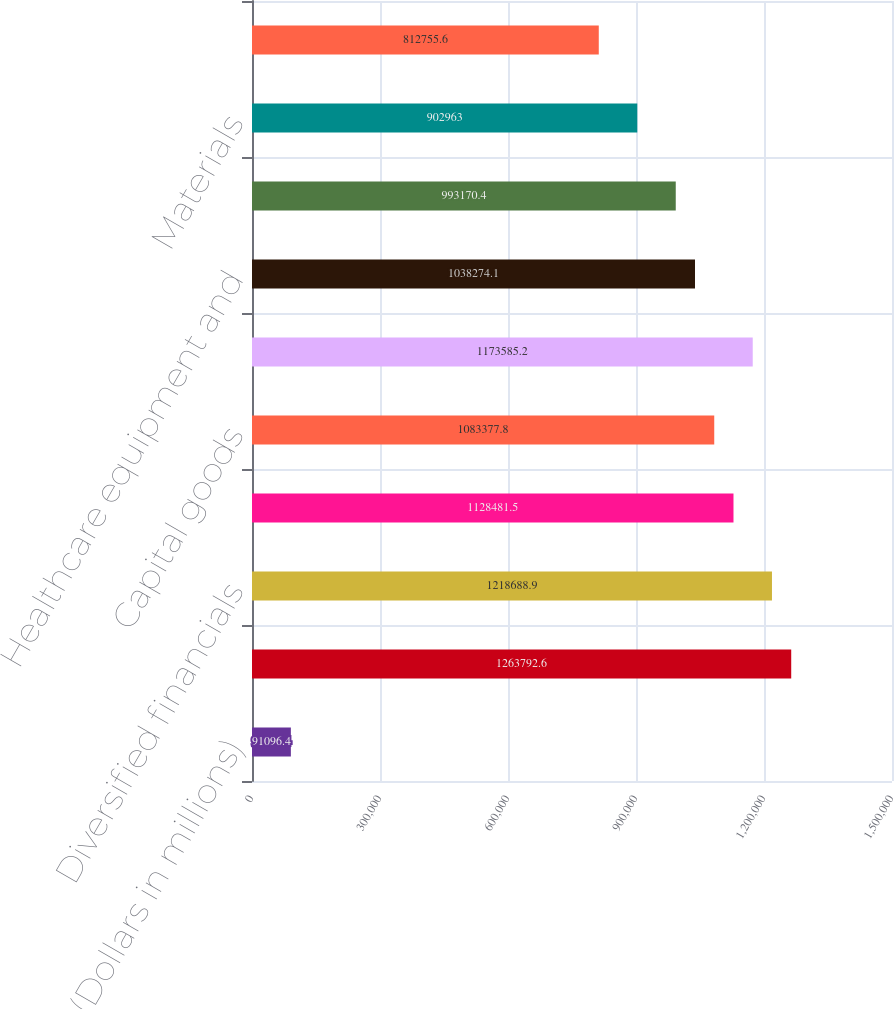Convert chart to OTSL. <chart><loc_0><loc_0><loc_500><loc_500><bar_chart><fcel>(Dollars in millions)<fcel>Real estate (3)<fcel>Diversified financials<fcel>Government and public<fcel>Capital goods<fcel>Retailing<fcel>Healthcare equipment and<fcel>Consumer services<fcel>Materials<fcel>Commercial services and<nl><fcel>91096.4<fcel>1.26379e+06<fcel>1.21869e+06<fcel>1.12848e+06<fcel>1.08338e+06<fcel>1.17359e+06<fcel>1.03827e+06<fcel>993170<fcel>902963<fcel>812756<nl></chart> 